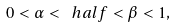Convert formula to latex. <formula><loc_0><loc_0><loc_500><loc_500>0 < \alpha < \ h a l f < \beta < 1 ,</formula> 